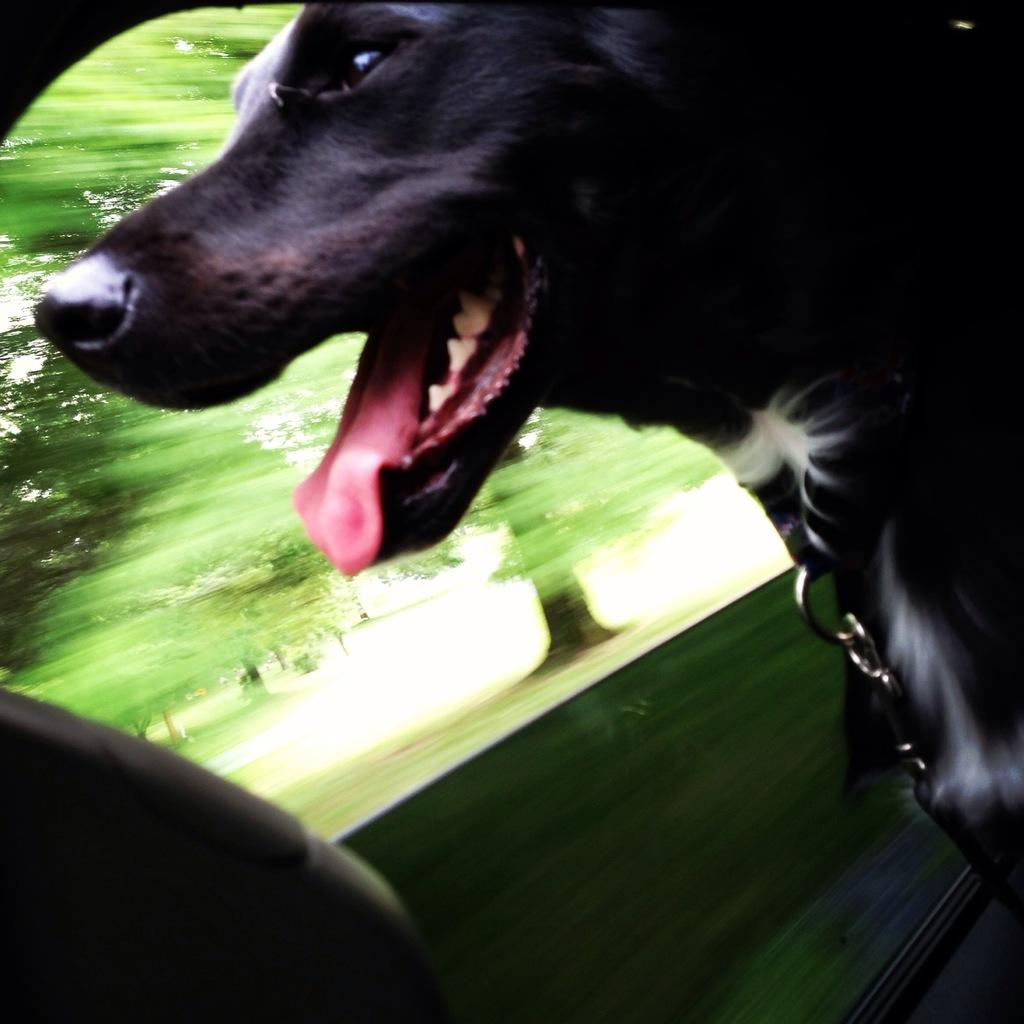What type of animal is in the vehicle in the image? There is a black dog in the vehicle. What can be seen in the background of the image? There are trees in the background of the image. What is the ground made of in the image? The ground appears to be grassy. How would you describe the quality of the image? The image is slightly blurry. What type of poison is the dog interested in during the scene? There is no poison present in the image, and the dog's interests are not mentioned or depicted. 